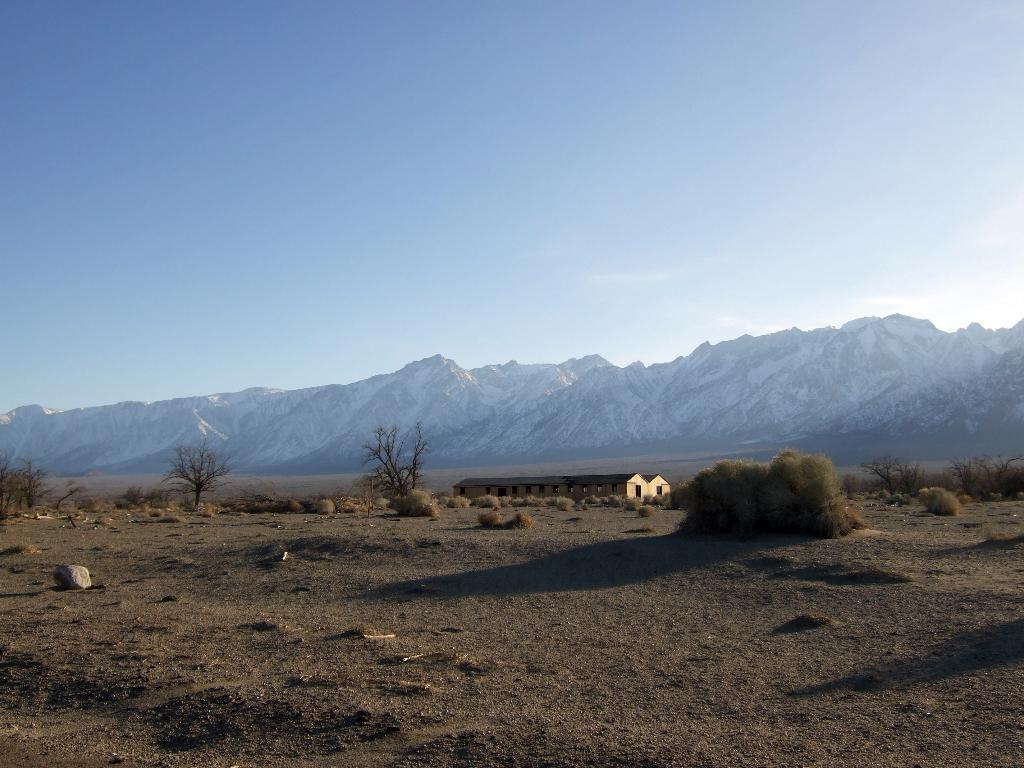What type of structures can be seen in the image? There are houses in the image. What type of vegetation is present in the image? There are trees in the image. What else can be seen in the image besides houses and trees? There is open land visible in the image. How many cacti can be seen in the image? There are no cacti present in the image; it features houses, trees, and open land. Can you see an airplane flying in the sky in the image? There is no airplane visible in the image. 